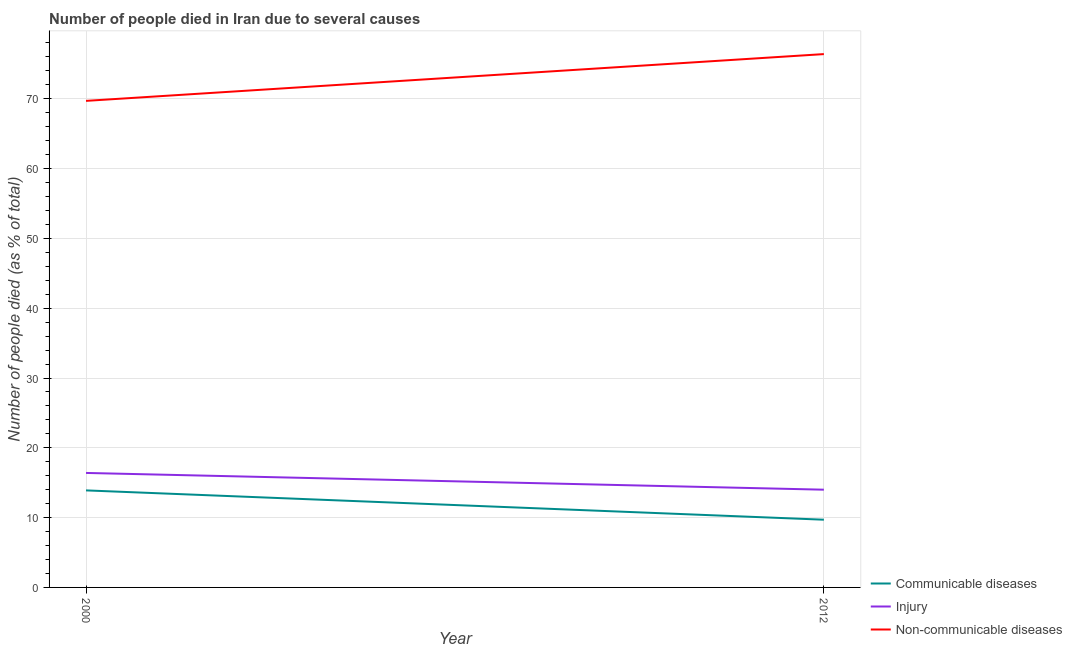How many different coloured lines are there?
Keep it short and to the point. 3. Does the line corresponding to number of people who died of communicable diseases intersect with the line corresponding to number of people who dies of non-communicable diseases?
Provide a succinct answer. No. Is the number of lines equal to the number of legend labels?
Offer a terse response. Yes. What is the number of people who dies of non-communicable diseases in 2012?
Make the answer very short. 76.4. Across all years, what is the minimum number of people who died of injury?
Offer a terse response. 14. In which year was the number of people who died of communicable diseases maximum?
Give a very brief answer. 2000. In which year was the number of people who dies of non-communicable diseases minimum?
Keep it short and to the point. 2000. What is the total number of people who died of injury in the graph?
Offer a very short reply. 30.4. What is the difference between the number of people who died of injury in 2000 and that in 2012?
Your response must be concise. 2.4. What is the difference between the number of people who died of communicable diseases in 2012 and the number of people who died of injury in 2000?
Your answer should be compact. -6.7. In the year 2000, what is the difference between the number of people who dies of non-communicable diseases and number of people who died of injury?
Offer a very short reply. 53.3. In how many years, is the number of people who died of injury greater than 58 %?
Make the answer very short. 0. What is the ratio of the number of people who dies of non-communicable diseases in 2000 to that in 2012?
Your answer should be very brief. 0.91. In how many years, is the number of people who died of injury greater than the average number of people who died of injury taken over all years?
Offer a very short reply. 1. Does the number of people who died of injury monotonically increase over the years?
Your answer should be compact. No. How many lines are there?
Offer a very short reply. 3. How many years are there in the graph?
Make the answer very short. 2. Are the values on the major ticks of Y-axis written in scientific E-notation?
Provide a short and direct response. No. Does the graph contain any zero values?
Your response must be concise. No. Does the graph contain grids?
Ensure brevity in your answer.  Yes. Where does the legend appear in the graph?
Ensure brevity in your answer.  Bottom right. How many legend labels are there?
Provide a short and direct response. 3. What is the title of the graph?
Make the answer very short. Number of people died in Iran due to several causes. What is the label or title of the Y-axis?
Offer a very short reply. Number of people died (as % of total). What is the Number of people died (as % of total) in Injury in 2000?
Provide a succinct answer. 16.4. What is the Number of people died (as % of total) of Non-communicable diseases in 2000?
Provide a short and direct response. 69.7. What is the Number of people died (as % of total) in Injury in 2012?
Offer a very short reply. 14. What is the Number of people died (as % of total) of Non-communicable diseases in 2012?
Your response must be concise. 76.4. Across all years, what is the maximum Number of people died (as % of total) of Non-communicable diseases?
Provide a short and direct response. 76.4. Across all years, what is the minimum Number of people died (as % of total) of Communicable diseases?
Offer a terse response. 9.7. Across all years, what is the minimum Number of people died (as % of total) of Injury?
Your answer should be compact. 14. Across all years, what is the minimum Number of people died (as % of total) in Non-communicable diseases?
Keep it short and to the point. 69.7. What is the total Number of people died (as % of total) in Communicable diseases in the graph?
Your answer should be compact. 23.6. What is the total Number of people died (as % of total) of Injury in the graph?
Provide a short and direct response. 30.4. What is the total Number of people died (as % of total) in Non-communicable diseases in the graph?
Make the answer very short. 146.1. What is the difference between the Number of people died (as % of total) in Injury in 2000 and that in 2012?
Offer a very short reply. 2.4. What is the difference between the Number of people died (as % of total) in Communicable diseases in 2000 and the Number of people died (as % of total) in Injury in 2012?
Offer a very short reply. -0.1. What is the difference between the Number of people died (as % of total) of Communicable diseases in 2000 and the Number of people died (as % of total) of Non-communicable diseases in 2012?
Provide a succinct answer. -62.5. What is the difference between the Number of people died (as % of total) in Injury in 2000 and the Number of people died (as % of total) in Non-communicable diseases in 2012?
Provide a succinct answer. -60. What is the average Number of people died (as % of total) in Communicable diseases per year?
Provide a succinct answer. 11.8. What is the average Number of people died (as % of total) in Non-communicable diseases per year?
Provide a succinct answer. 73.05. In the year 2000, what is the difference between the Number of people died (as % of total) in Communicable diseases and Number of people died (as % of total) in Non-communicable diseases?
Offer a very short reply. -55.8. In the year 2000, what is the difference between the Number of people died (as % of total) in Injury and Number of people died (as % of total) in Non-communicable diseases?
Provide a succinct answer. -53.3. In the year 2012, what is the difference between the Number of people died (as % of total) of Communicable diseases and Number of people died (as % of total) of Injury?
Your response must be concise. -4.3. In the year 2012, what is the difference between the Number of people died (as % of total) in Communicable diseases and Number of people died (as % of total) in Non-communicable diseases?
Your answer should be very brief. -66.7. In the year 2012, what is the difference between the Number of people died (as % of total) in Injury and Number of people died (as % of total) in Non-communicable diseases?
Give a very brief answer. -62.4. What is the ratio of the Number of people died (as % of total) of Communicable diseases in 2000 to that in 2012?
Your answer should be very brief. 1.43. What is the ratio of the Number of people died (as % of total) of Injury in 2000 to that in 2012?
Provide a succinct answer. 1.17. What is the ratio of the Number of people died (as % of total) of Non-communicable diseases in 2000 to that in 2012?
Make the answer very short. 0.91. What is the difference between the highest and the second highest Number of people died (as % of total) in Injury?
Provide a short and direct response. 2.4. What is the difference between the highest and the second highest Number of people died (as % of total) of Non-communicable diseases?
Ensure brevity in your answer.  6.7. What is the difference between the highest and the lowest Number of people died (as % of total) of Communicable diseases?
Ensure brevity in your answer.  4.2. What is the difference between the highest and the lowest Number of people died (as % of total) of Non-communicable diseases?
Provide a short and direct response. 6.7. 